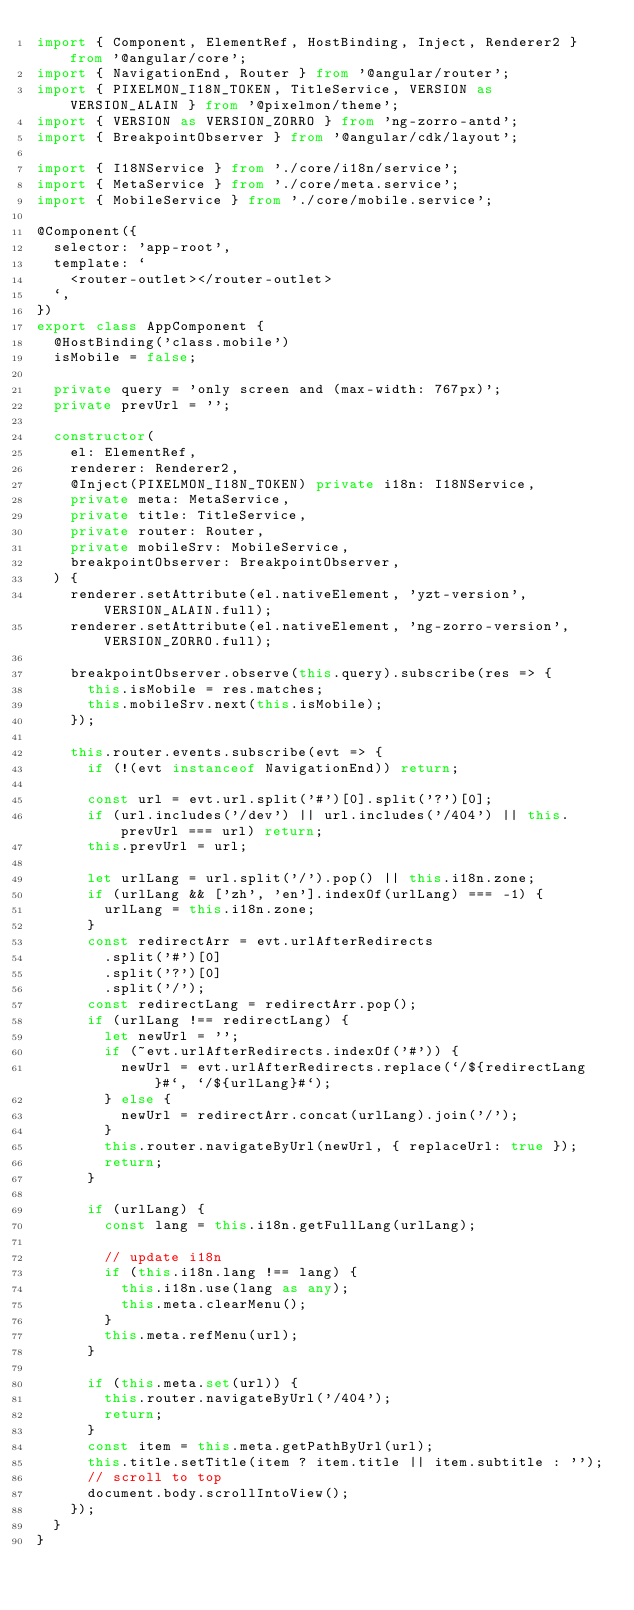Convert code to text. <code><loc_0><loc_0><loc_500><loc_500><_TypeScript_>import { Component, ElementRef, HostBinding, Inject, Renderer2 } from '@angular/core';
import { NavigationEnd, Router } from '@angular/router';
import { PIXELMON_I18N_TOKEN, TitleService, VERSION as VERSION_ALAIN } from '@pixelmon/theme';
import { VERSION as VERSION_ZORRO } from 'ng-zorro-antd';
import { BreakpointObserver } from '@angular/cdk/layout';

import { I18NService } from './core/i18n/service';
import { MetaService } from './core/meta.service';
import { MobileService } from './core/mobile.service';

@Component({
  selector: 'app-root',
  template: `
    <router-outlet></router-outlet>
  `,
})
export class AppComponent {
  @HostBinding('class.mobile')
  isMobile = false;

  private query = 'only screen and (max-width: 767px)';
  private prevUrl = '';

  constructor(
    el: ElementRef,
    renderer: Renderer2,
    @Inject(PIXELMON_I18N_TOKEN) private i18n: I18NService,
    private meta: MetaService,
    private title: TitleService,
    private router: Router,
    private mobileSrv: MobileService,
    breakpointObserver: BreakpointObserver,
  ) {
    renderer.setAttribute(el.nativeElement, 'yzt-version', VERSION_ALAIN.full);
    renderer.setAttribute(el.nativeElement, 'ng-zorro-version', VERSION_ZORRO.full);

    breakpointObserver.observe(this.query).subscribe(res => {
      this.isMobile = res.matches;
      this.mobileSrv.next(this.isMobile);
    });

    this.router.events.subscribe(evt => {
      if (!(evt instanceof NavigationEnd)) return;

      const url = evt.url.split('#')[0].split('?')[0];
      if (url.includes('/dev') || url.includes('/404') || this.prevUrl === url) return;
      this.prevUrl = url;

      let urlLang = url.split('/').pop() || this.i18n.zone;
      if (urlLang && ['zh', 'en'].indexOf(urlLang) === -1) {
        urlLang = this.i18n.zone;
      }
      const redirectArr = evt.urlAfterRedirects
        .split('#')[0]
        .split('?')[0]
        .split('/');
      const redirectLang = redirectArr.pop();
      if (urlLang !== redirectLang) {
        let newUrl = '';
        if (~evt.urlAfterRedirects.indexOf('#')) {
          newUrl = evt.urlAfterRedirects.replace(`/${redirectLang}#`, `/${urlLang}#`);
        } else {
          newUrl = redirectArr.concat(urlLang).join('/');
        }
        this.router.navigateByUrl(newUrl, { replaceUrl: true });
        return;
      }

      if (urlLang) {
        const lang = this.i18n.getFullLang(urlLang);

        // update i18n
        if (this.i18n.lang !== lang) {
          this.i18n.use(lang as any);
          this.meta.clearMenu();
        }
        this.meta.refMenu(url);
      }

      if (this.meta.set(url)) {
        this.router.navigateByUrl('/404');
        return;
      }
      const item = this.meta.getPathByUrl(url);
      this.title.setTitle(item ? item.title || item.subtitle : '');
      // scroll to top
      document.body.scrollIntoView();
    });
  }
}
</code> 